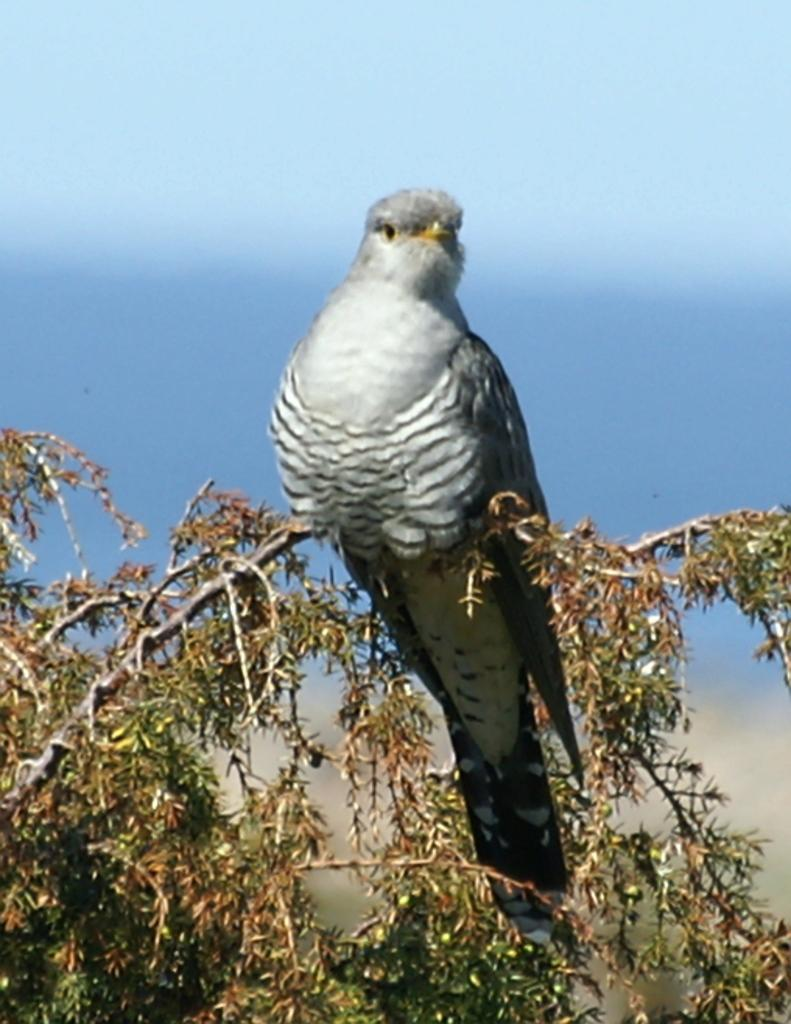What type of animal can be seen in the image? There is a bird in the image. Where is the bird located? The bird is on a tree. What can be seen in the background of the image? The sky is blue and cloudy in the background. What type of veil is the bird wearing in the image? There is no veil present in the image, and the bird is not wearing any clothing. 